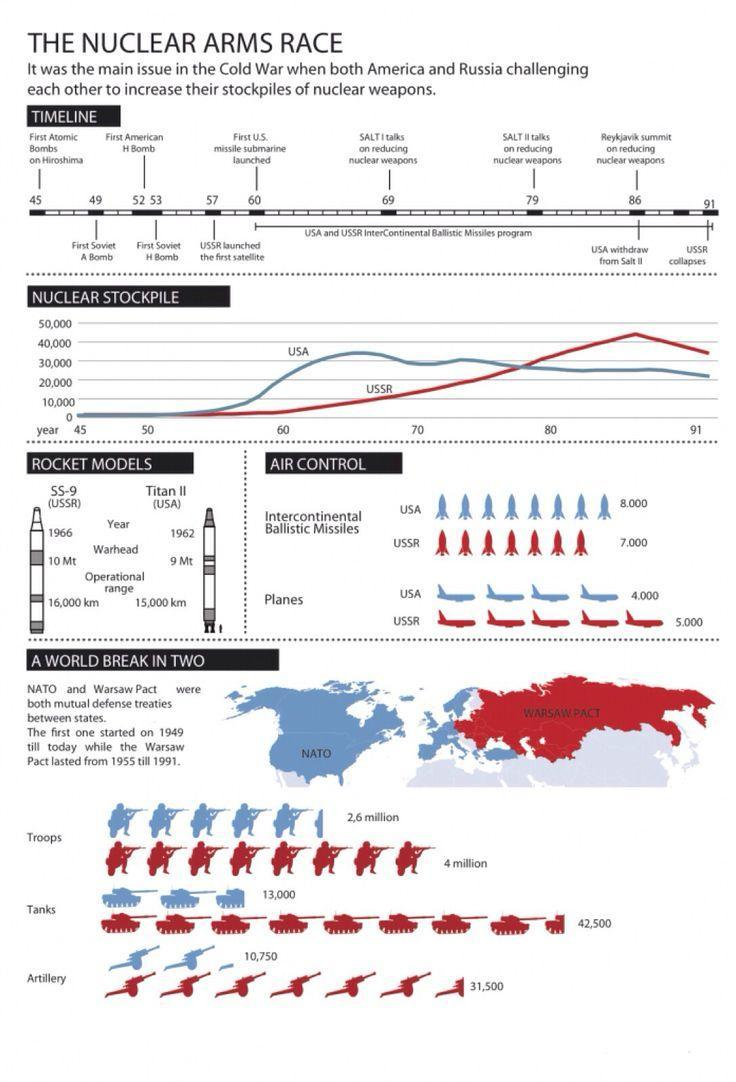How many military tankers were deployed in NATO?
Answer the question with a short phrase. 13,000 When was the first Titan II missile launched by the US? 1962 What is the number of artilleries deployed in the Warsaw Pact? 31,500 What is the warhead length of Titan II? 9 Mt What is the operational range of SS-9? 16,000 km How many troops were deployed in the Warsaw Pact? 4 million 